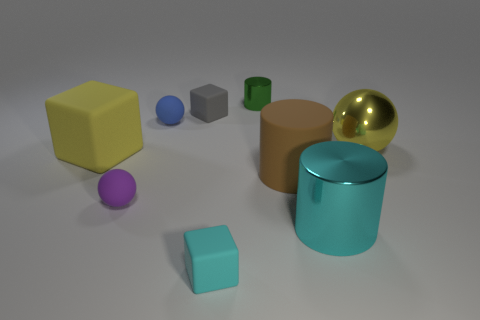There is a sphere to the right of the large cyan metal object; is it the same color as the block that is left of the gray matte object?
Your response must be concise. Yes. What number of rubber balls have the same size as the gray rubber block?
Offer a terse response. 2. There is a metallic cylinder that is right of the green metallic thing; does it have the same size as the small metallic cylinder?
Offer a terse response. No. What shape is the green shiny object?
Your answer should be very brief. Cylinder. There is a metallic thing that is the same color as the big block; what is its size?
Make the answer very short. Large. Is the cylinder to the right of the brown cylinder made of the same material as the tiny blue object?
Provide a succinct answer. No. Are there any metallic balls that have the same color as the big matte block?
Give a very brief answer. Yes. Does the matte object in front of the tiny purple ball have the same shape as the large object that is to the left of the small green cylinder?
Your answer should be very brief. Yes. Is there a yellow object that has the same material as the big brown cylinder?
Ensure brevity in your answer.  Yes. What number of blue things are tiny matte objects or metallic balls?
Offer a very short reply. 1. 